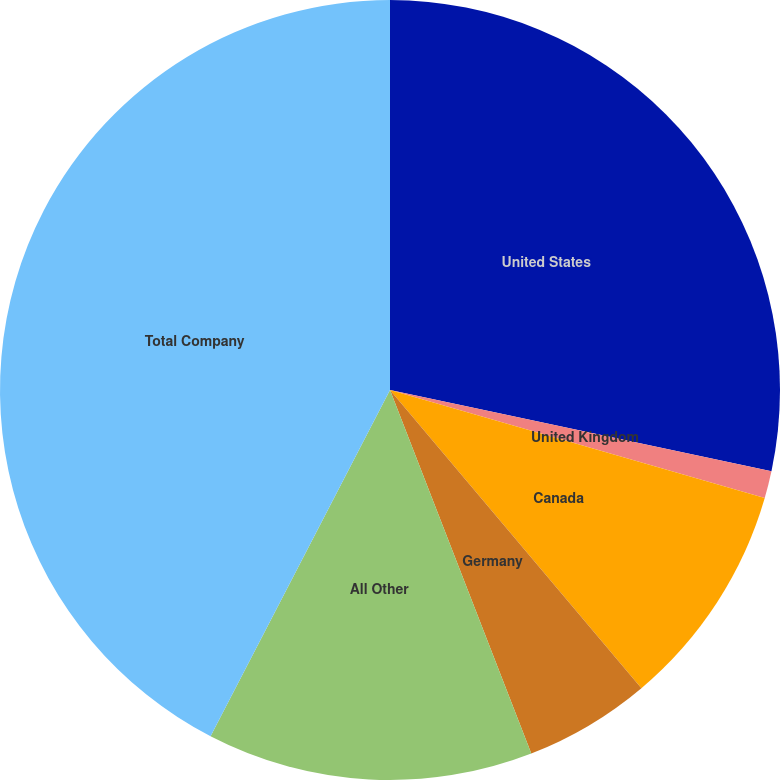Convert chart. <chart><loc_0><loc_0><loc_500><loc_500><pie_chart><fcel>United States<fcel>United Kingdom<fcel>Canada<fcel>Germany<fcel>All Other<fcel>Total Company<nl><fcel>28.34%<fcel>1.13%<fcel>9.38%<fcel>5.25%<fcel>13.51%<fcel>42.39%<nl></chart> 